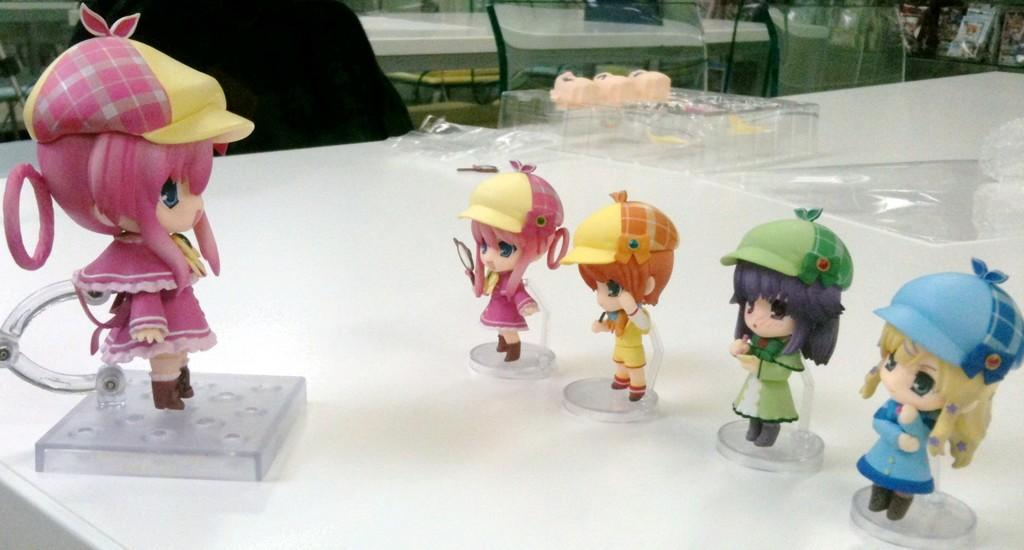What type of furniture is present in the image? There is a table in the image. What is the color of the table? The table is white in color. What objects are placed on the table? There are dolls placed on the table. Can you describe the surrounding area in the image? There are other tables visible behind the main table. How many friends are sitting on the table in the image? There are no friends sitting on the table in the image; it is a table with dolls placed on it. What type of bird can be seen rubbing its wings on the table? There is no bird present in the image, let alone one rubbing its wings on the table. 